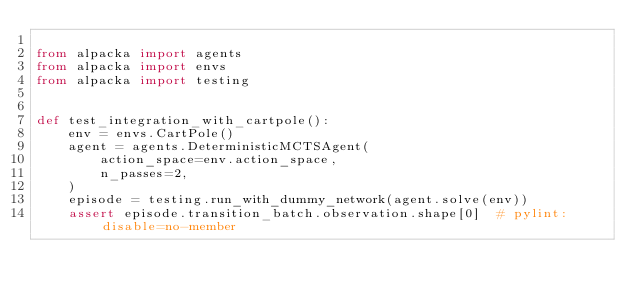<code> <loc_0><loc_0><loc_500><loc_500><_Python_>
from alpacka import agents
from alpacka import envs
from alpacka import testing


def test_integration_with_cartpole():
    env = envs.CartPole()
    agent = agents.DeterministicMCTSAgent(
        action_space=env.action_space,
        n_passes=2,
    )
    episode = testing.run_with_dummy_network(agent.solve(env))
    assert episode.transition_batch.observation.shape[0]  # pylint: disable=no-member
</code> 